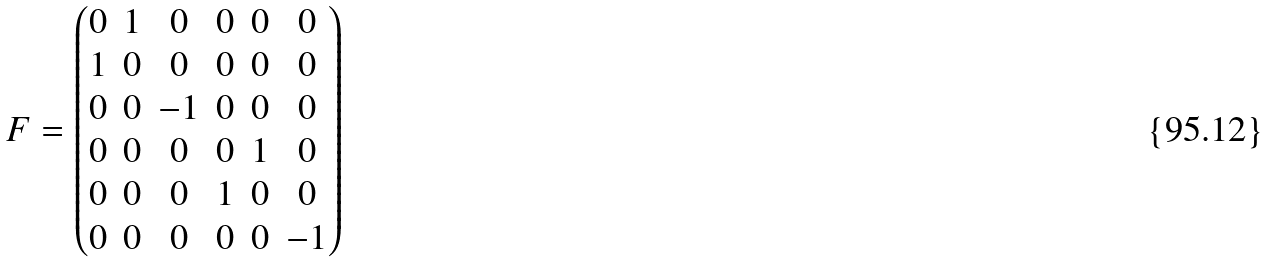Convert formula to latex. <formula><loc_0><loc_0><loc_500><loc_500>F = \begin{pmatrix} 0 & 1 & 0 & 0 & 0 & 0 \\ 1 & 0 & 0 & 0 & 0 & 0 \\ 0 & 0 & - 1 & 0 & 0 & 0 \\ 0 & 0 & 0 & 0 & 1 & 0 \\ 0 & 0 & 0 & 1 & 0 & 0 \\ 0 & 0 & 0 & 0 & 0 & - 1 \end{pmatrix}</formula> 